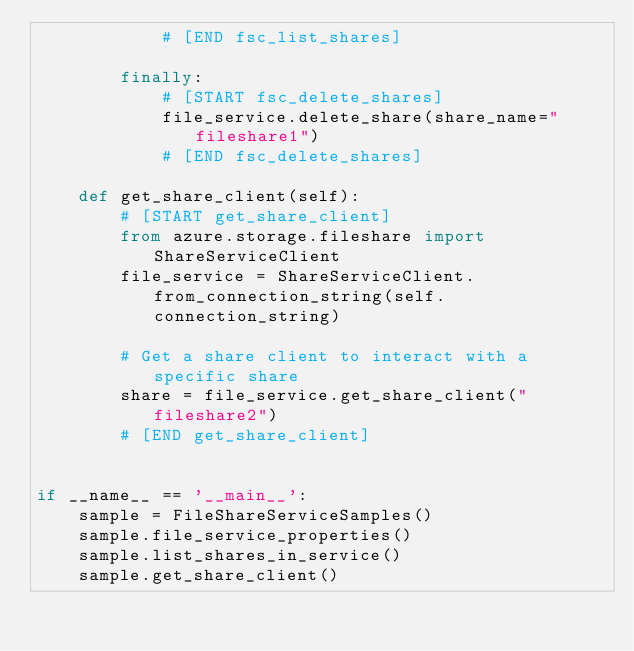<code> <loc_0><loc_0><loc_500><loc_500><_Python_>            # [END fsc_list_shares]

        finally:
            # [START fsc_delete_shares]
            file_service.delete_share(share_name="fileshare1")
            # [END fsc_delete_shares]

    def get_share_client(self):
        # [START get_share_client]
        from azure.storage.fileshare import ShareServiceClient
        file_service = ShareServiceClient.from_connection_string(self.connection_string)

        # Get a share client to interact with a specific share
        share = file_service.get_share_client("fileshare2")
        # [END get_share_client]


if __name__ == '__main__':
    sample = FileShareServiceSamples()
    sample.file_service_properties()
    sample.list_shares_in_service()
    sample.get_share_client()

</code> 